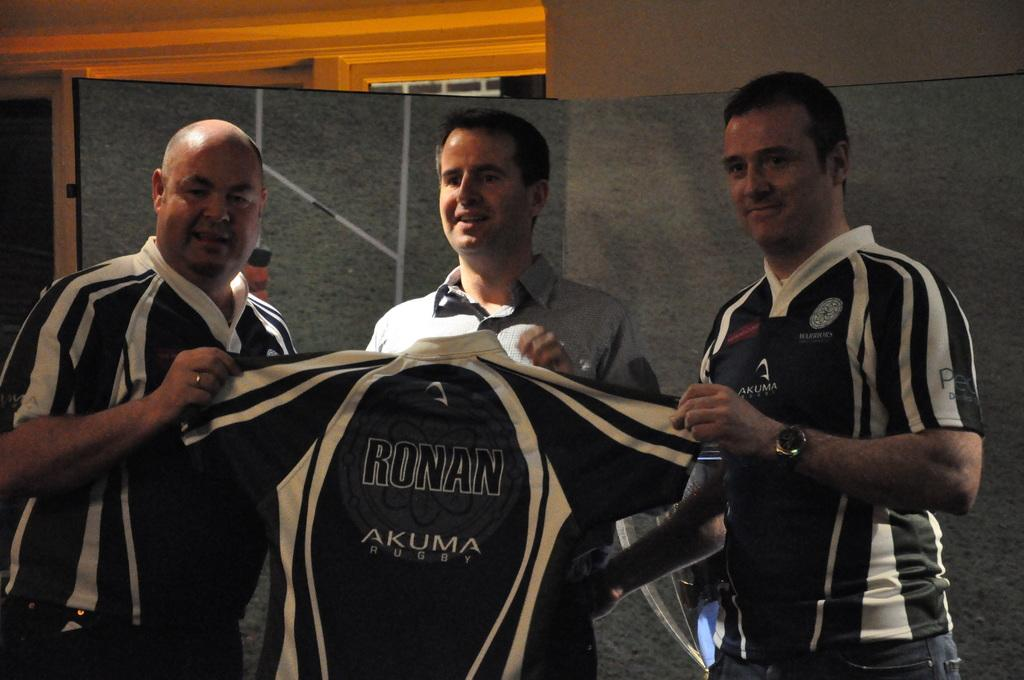How many people are in the image? There are three men in the image. What are the men holding in the image? The men are holding a T-shirt. What can be seen in the background of the image? There is a wall in the background of the image. How many babies are crawling on the floor in the image? There are no babies present in the image. What part of the body is the foot mentioned in the image? There is no mention of a foot in the image. 